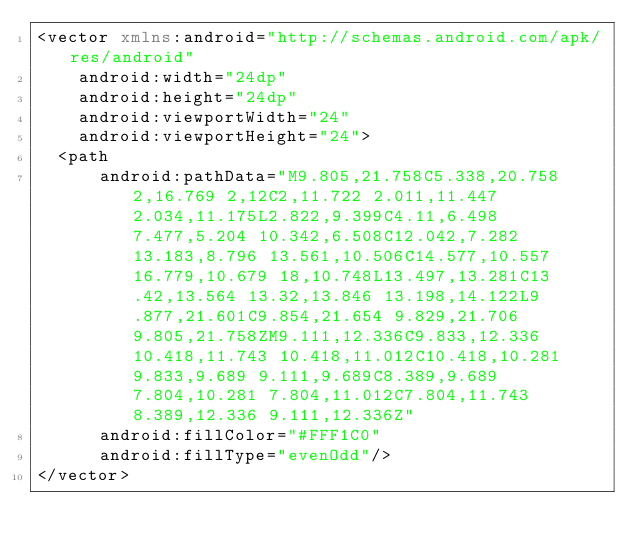Convert code to text. <code><loc_0><loc_0><loc_500><loc_500><_XML_><vector xmlns:android="http://schemas.android.com/apk/res/android"
    android:width="24dp"
    android:height="24dp"
    android:viewportWidth="24"
    android:viewportHeight="24">
  <path
      android:pathData="M9.805,21.758C5.338,20.758 2,16.769 2,12C2,11.722 2.011,11.447 2.034,11.175L2.822,9.399C4.11,6.498 7.477,5.204 10.342,6.508C12.042,7.282 13.183,8.796 13.561,10.506C14.577,10.557 16.779,10.679 18,10.748L13.497,13.281C13.42,13.564 13.32,13.846 13.198,14.122L9.877,21.601C9.854,21.654 9.829,21.706 9.805,21.758ZM9.111,12.336C9.833,12.336 10.418,11.743 10.418,11.012C10.418,10.281 9.833,9.689 9.111,9.689C8.389,9.689 7.804,10.281 7.804,11.012C7.804,11.743 8.389,12.336 9.111,12.336Z"
      android:fillColor="#FFF1C0"
      android:fillType="evenOdd"/>
</vector>
</code> 